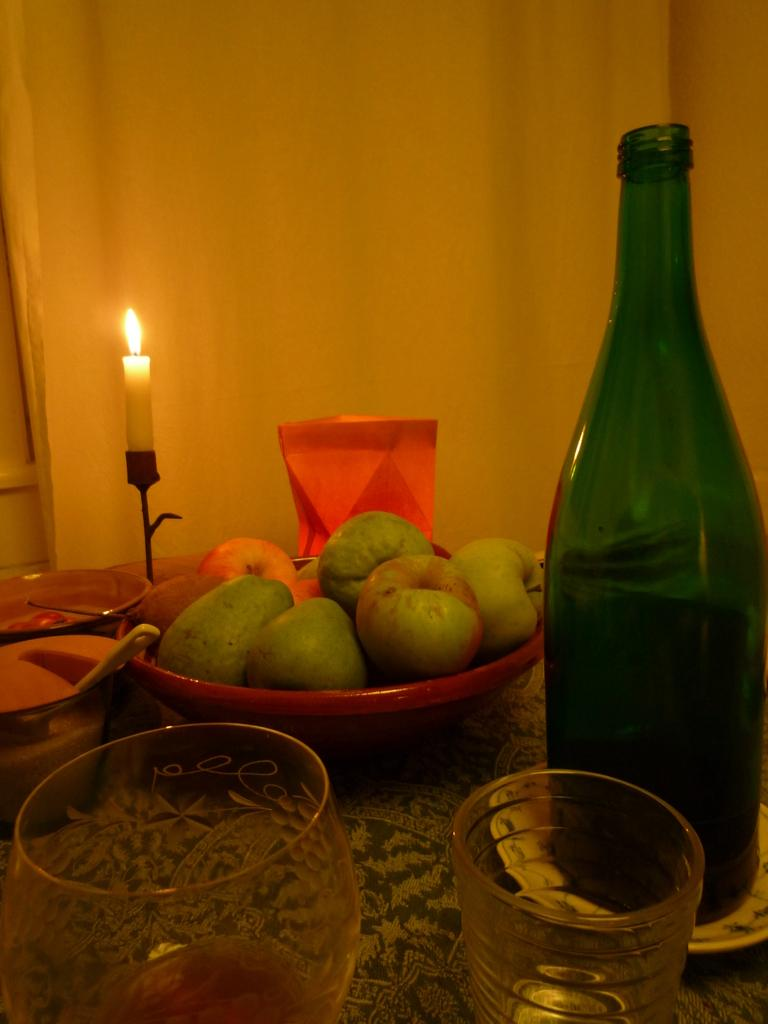What piece of furniture is present in the image? There is a table in the image. What is placed on the table? There is a wine bottle, glasses, and a bowl with fruits on the table. Is there any lighting element in the image? Yes, there is a candle on a stand in the image. What type of impulse is being generated by the stage in the image? There is no stage present in the image, so no impulse can be generated from it. 